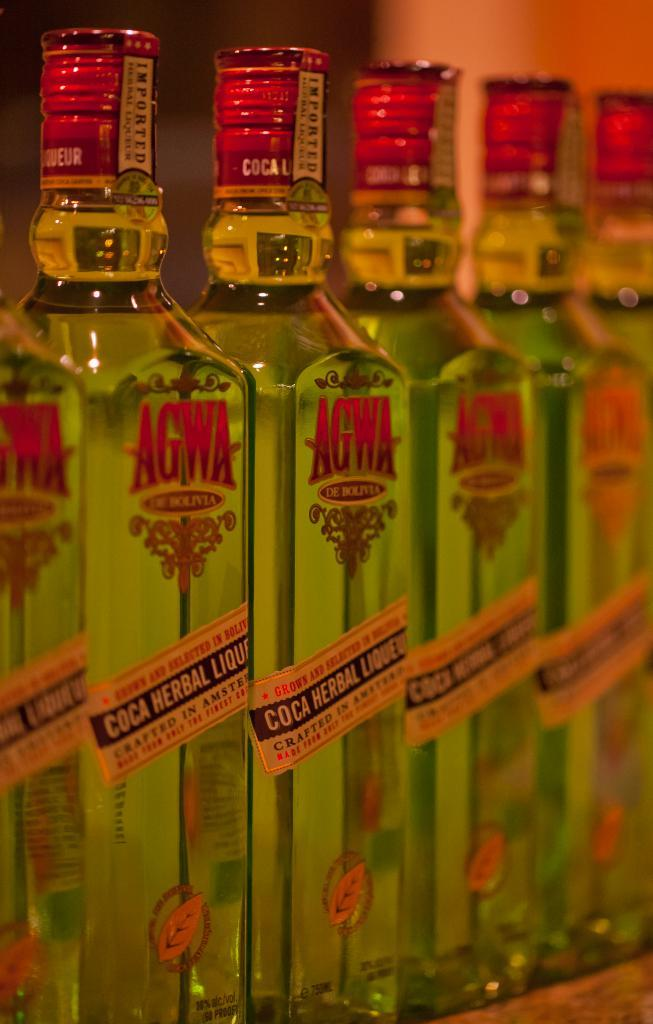Provide a one-sentence caption for the provided image. Bottles of AGWA, a Coca Herbal Liquor, are lined up next to each other. 